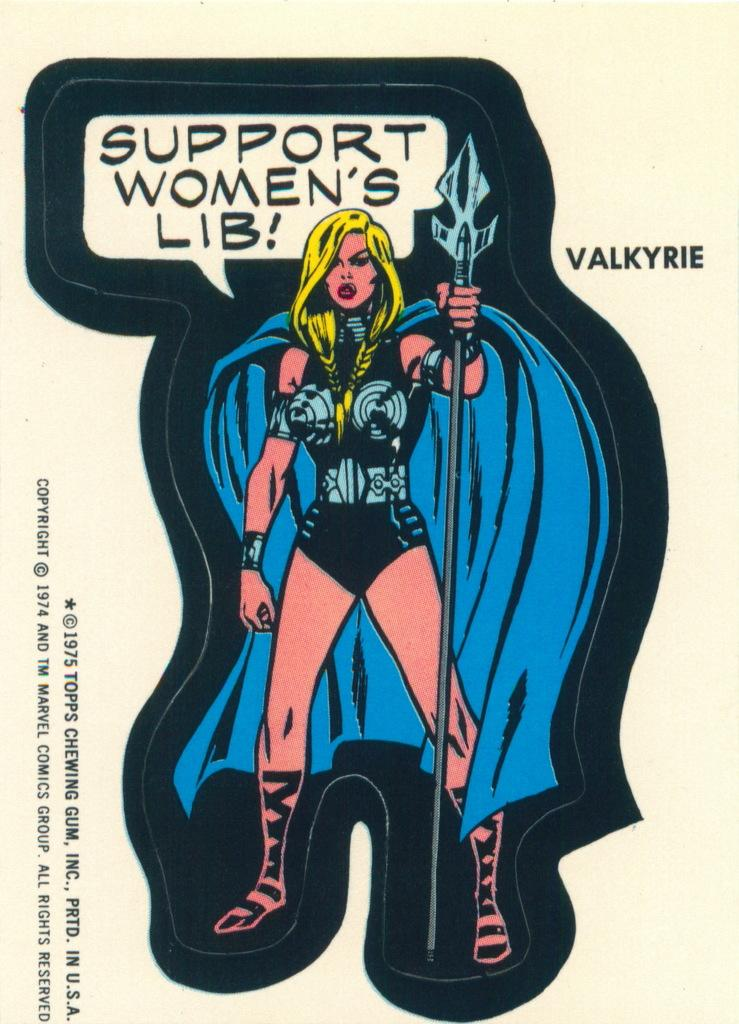What is the main subject of the image? There is a picture of a woman in the image. What is the woman doing in the image? The woman is standing in the image. What is the woman wearing in the image? The woman is wearing a dress in the image. What is the woman holding in the image? The woman is holding a weapon in the image. Is there any text or writing on the image? Yes, there is text or writing on the image. How many cherries are on the stick in the image? There is no stick or cherries present in the image. 